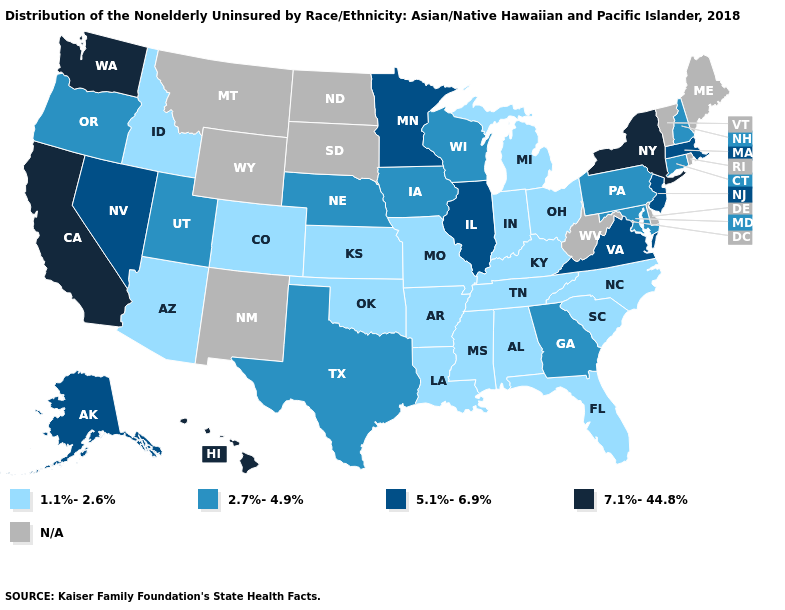Among the states that border Nebraska , which have the highest value?
Be succinct. Iowa. What is the value of Kansas?
Answer briefly. 1.1%-2.6%. How many symbols are there in the legend?
Answer briefly. 5. What is the highest value in the West ?
Write a very short answer. 7.1%-44.8%. Does Connecticut have the lowest value in the Northeast?
Be succinct. Yes. What is the value of West Virginia?
Short answer required. N/A. What is the highest value in the South ?
Give a very brief answer. 5.1%-6.9%. What is the value of Oklahoma?
Give a very brief answer. 1.1%-2.6%. Which states have the highest value in the USA?
Concise answer only. California, Hawaii, New York, Washington. Does Washington have the highest value in the USA?
Quick response, please. Yes. Among the states that border New Mexico , does Colorado have the highest value?
Answer briefly. No. What is the value of New Mexico?
Be succinct. N/A. Does California have the highest value in the USA?
Answer briefly. Yes. What is the lowest value in the USA?
Short answer required. 1.1%-2.6%. 